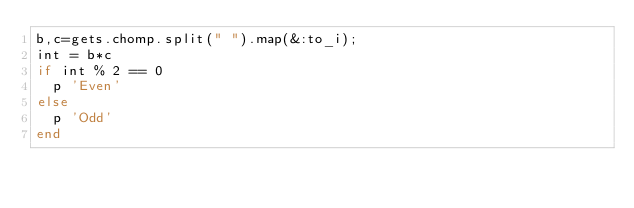Convert code to text. <code><loc_0><loc_0><loc_500><loc_500><_Ruby_>b,c=gets.chomp.split(" ").map(&:to_i);
int = b*c
if int % 2 == 0
  p 'Even'
else
  p 'Odd'
end</code> 